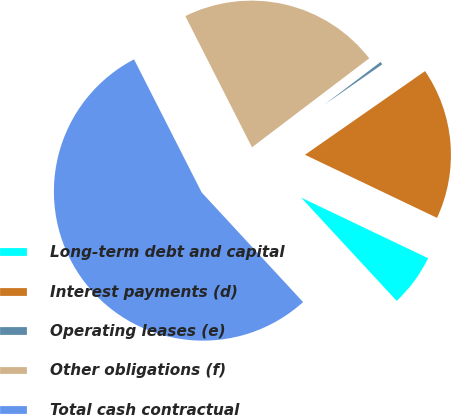<chart> <loc_0><loc_0><loc_500><loc_500><pie_chart><fcel>Long-term debt and capital<fcel>Interest payments (d)<fcel>Operating leases (e)<fcel>Other obligations (f)<fcel>Total cash contractual<nl><fcel>6.03%<fcel>16.78%<fcel>0.65%<fcel>22.15%<fcel>54.4%<nl></chart> 